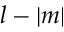<formula> <loc_0><loc_0><loc_500><loc_500>l - | m |</formula> 